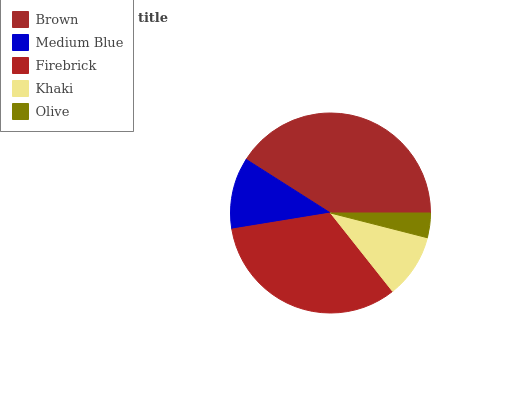Is Olive the minimum?
Answer yes or no. Yes. Is Brown the maximum?
Answer yes or no. Yes. Is Medium Blue the minimum?
Answer yes or no. No. Is Medium Blue the maximum?
Answer yes or no. No. Is Brown greater than Medium Blue?
Answer yes or no. Yes. Is Medium Blue less than Brown?
Answer yes or no. Yes. Is Medium Blue greater than Brown?
Answer yes or no. No. Is Brown less than Medium Blue?
Answer yes or no. No. Is Medium Blue the high median?
Answer yes or no. Yes. Is Medium Blue the low median?
Answer yes or no. Yes. Is Brown the high median?
Answer yes or no. No. Is Khaki the low median?
Answer yes or no. No. 